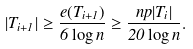<formula> <loc_0><loc_0><loc_500><loc_500>| T _ { i + 1 } | \geq \frac { e ( T _ { i + 1 } ) } { 6 \log n } \geq \frac { n p | T _ { i } | } { 2 0 \log n } .</formula> 